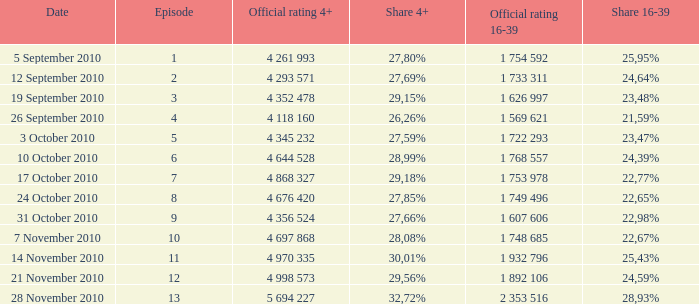What is the official 4+ rating of the episode with a 16-39 share of 2 4 998 573. 